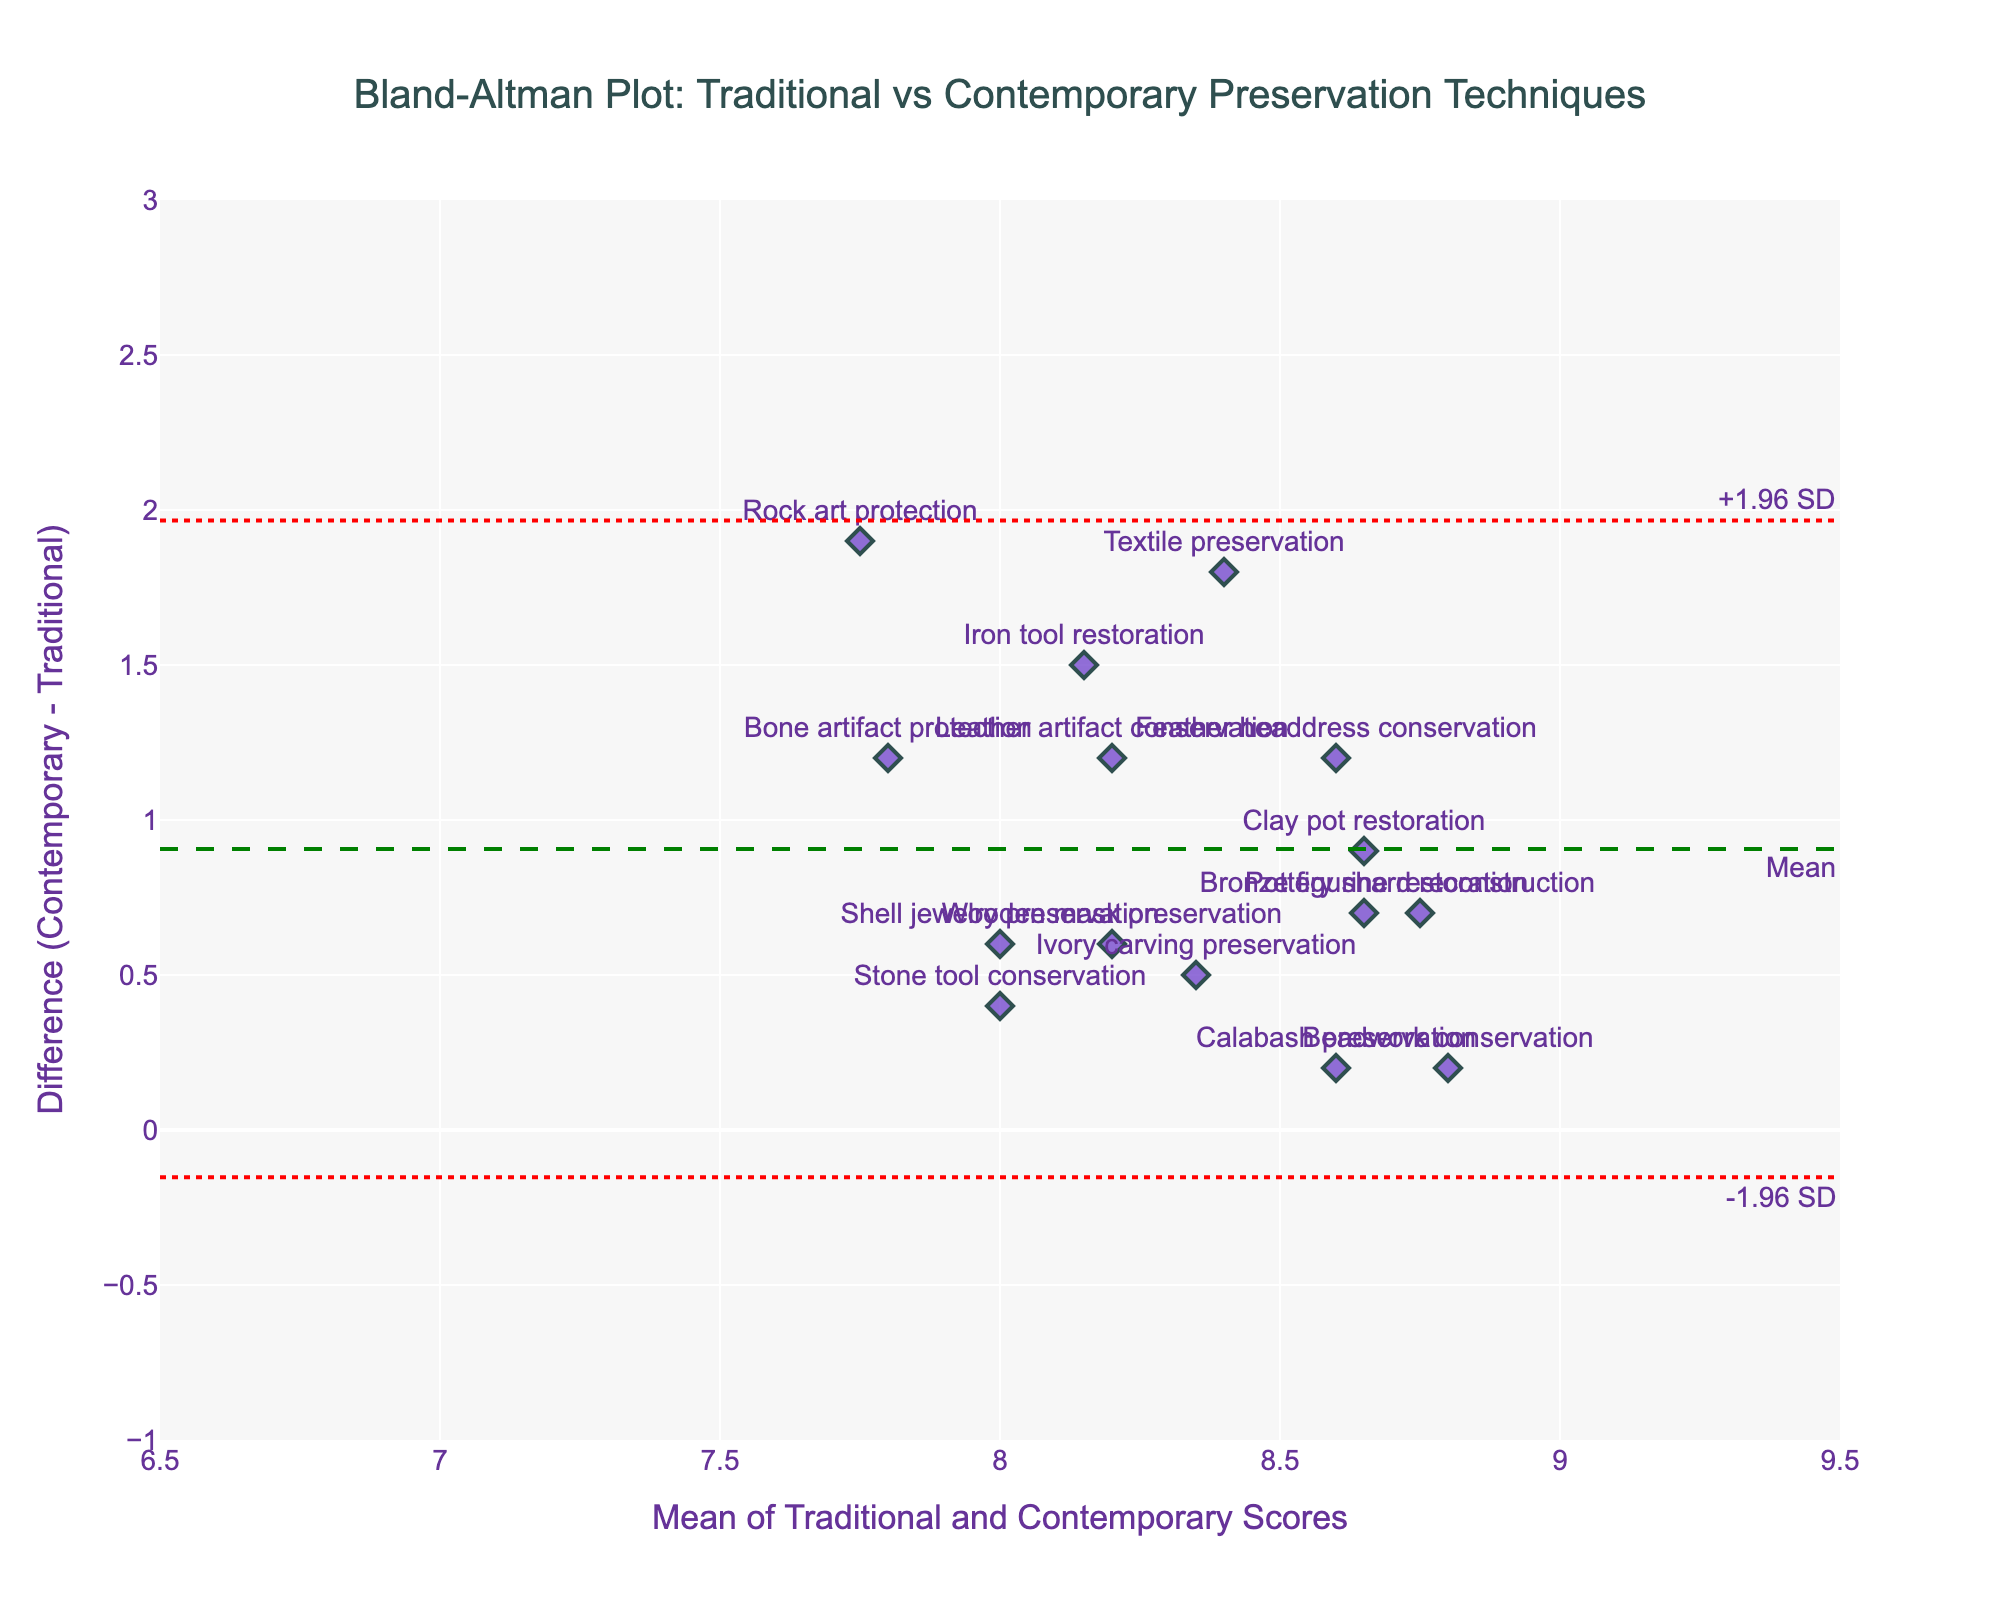What is the title of the plot? The title is usually displayed at the top of the plot. We can see it is "Bland-Altman Plot: Traditional vs Contemporary Preservation Techniques."
Answer: Bland-Altman Plot: Traditional vs Contemporary Preservation Techniques How many data points are displayed in the plot? Each method represents a data point, and there are 15 methods listed in the data.
Answer: 15 What are the x-axis and y-axis titles? The x-axis represents the "Mean of Traditional and Contemporary Scores," and the y-axis represents the "Difference (Contemporary - Traditional)."
Answer: Mean of Traditional and Contemporary Scores; Difference (Contemporary - Traditional) Which method has the highest mean score? To find the highest mean score, we calculate the average for each method, then identify the maximum. "Textile preservation" shows the highest mean score with 8.4.
Answer: Textile preservation What is the average difference between the traditional and contemporary methods? The average difference was calculated and represented as a dashed green line. Observing this line in the plot, we see it is around 0.94.
Answer: 0.94 Which method had the largest positive difference between contemporary and traditional scores? Look for the point furthest above the mean line; "Textile preservation" has the highest positive difference.
Answer: Textile preservation What are the upper and lower limits (-1.96 SD and +1.96 SD) of the differences? These are marked with red dotted lines in the plot. The upper limit is about 2.49, and the lower limit is around -0.61.
Answer: 2.49, -0.61 Which methods lie outside the 1.96 SD limits? Points outside the red dashed lines (-1.96 SD and +1.96 SD) are considered. No points lie outside these lines in this plot.
Answer: None Which method has a difference closest to zero? Look at the points situated near the green dashed line (representing a difference of 0.94). "Beadwork conservation," having a difference close to this line at around 0.2, is closest to zero.
Answer: Beadwork conservation Which method has the largest negative difference between contemporary and traditional scores? Look for the point furthest below the mean line; "Rock art protection" has the largest negative difference.
Answer: Rock art protection 